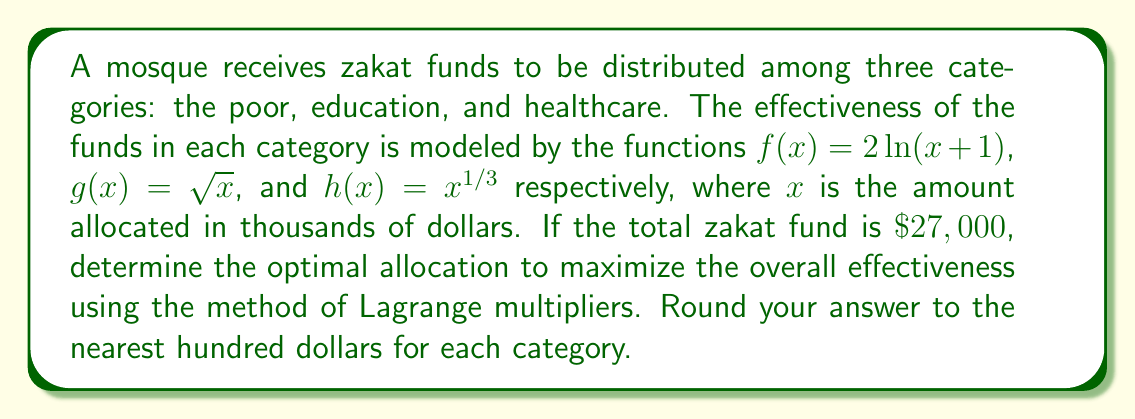Can you answer this question? Let's approach this step-by-step using the method of Lagrange multipliers:

1) Let $x$, $y$, and $z$ represent the amounts (in thousands of dollars) allocated to the poor, education, and healthcare respectively.

2) Our objective function is:
   $$F(x,y,z) = f(x) + g(y) + h(z) = 2\ln(x+1) + \sqrt{y} + z^{1/3}$$

3) The constraint is:
   $$x + y + z = 27$$

4) Form the Lagrangian:
   $$L(x,y,z,\lambda) = 2\ln(x+1) + \sqrt{y} + z^{1/3} - \lambda(x + y + z - 27)$$

5) Take partial derivatives and set them equal to zero:
   $$\frac{\partial L}{\partial x} = \frac{2}{x+1} - \lambda = 0$$
   $$\frac{\partial L}{\partial y} = \frac{1}{2\sqrt{y}} - \lambda = 0$$
   $$\frac{\partial L}{\partial z} = \frac{1}{3z^{2/3}} - \lambda = 0$$
   $$\frac{\partial L}{\partial \lambda} = x + y + z - 27 = 0$$

6) From these equations, we can derive:
   $$2(x+1) = 4\sqrt{y} = 6z^{2/3}$$

7) Let $2(x+1) = t$. Then:
   $$x = \frac{t}{2} - 1, y = (\frac{t}{4})^2, z = (\frac{t}{6})^3$$

8) Substitute these into the constraint equation:
   $$(\frac{t}{2} - 1) + (\frac{t}{4})^2 + (\frac{t}{6})^3 = 27$$

9) Solve this equation numerically to get $t \approx 18.37$

10) Substitute back to get:
    $$x \approx 8.19, y \approx 21.07, z \approx 24.74$$

11) The total of these is 54, which represents $\$54,000$. We need to scale this down to $\$27,000$ by dividing each value by 2.

12) Final allocation (in thousands of dollars):
    $$x \approx 4.09, y \approx 10.54, z \approx 12.37$$

13) Rounding to the nearest hundred dollars:
    Poor: $\$4,100$
    Education: $\$10,500$
    Healthcare: $\$12,400$
Answer: Poor: $\$4,100$, Education: $\$10,500$, Healthcare: $\$12,400$ 